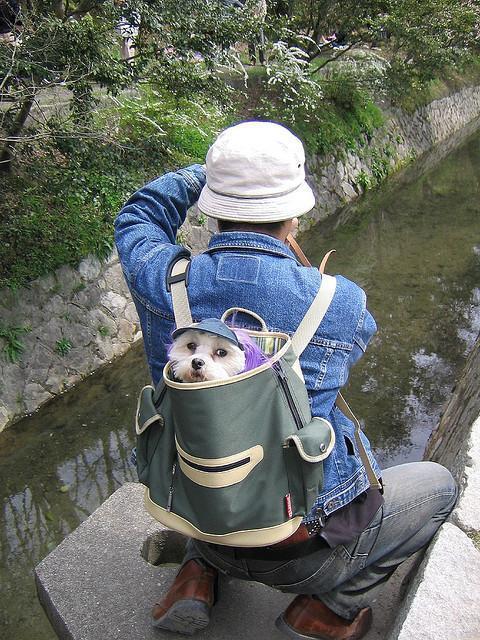How many horses can be seen?
Give a very brief answer. 0. 